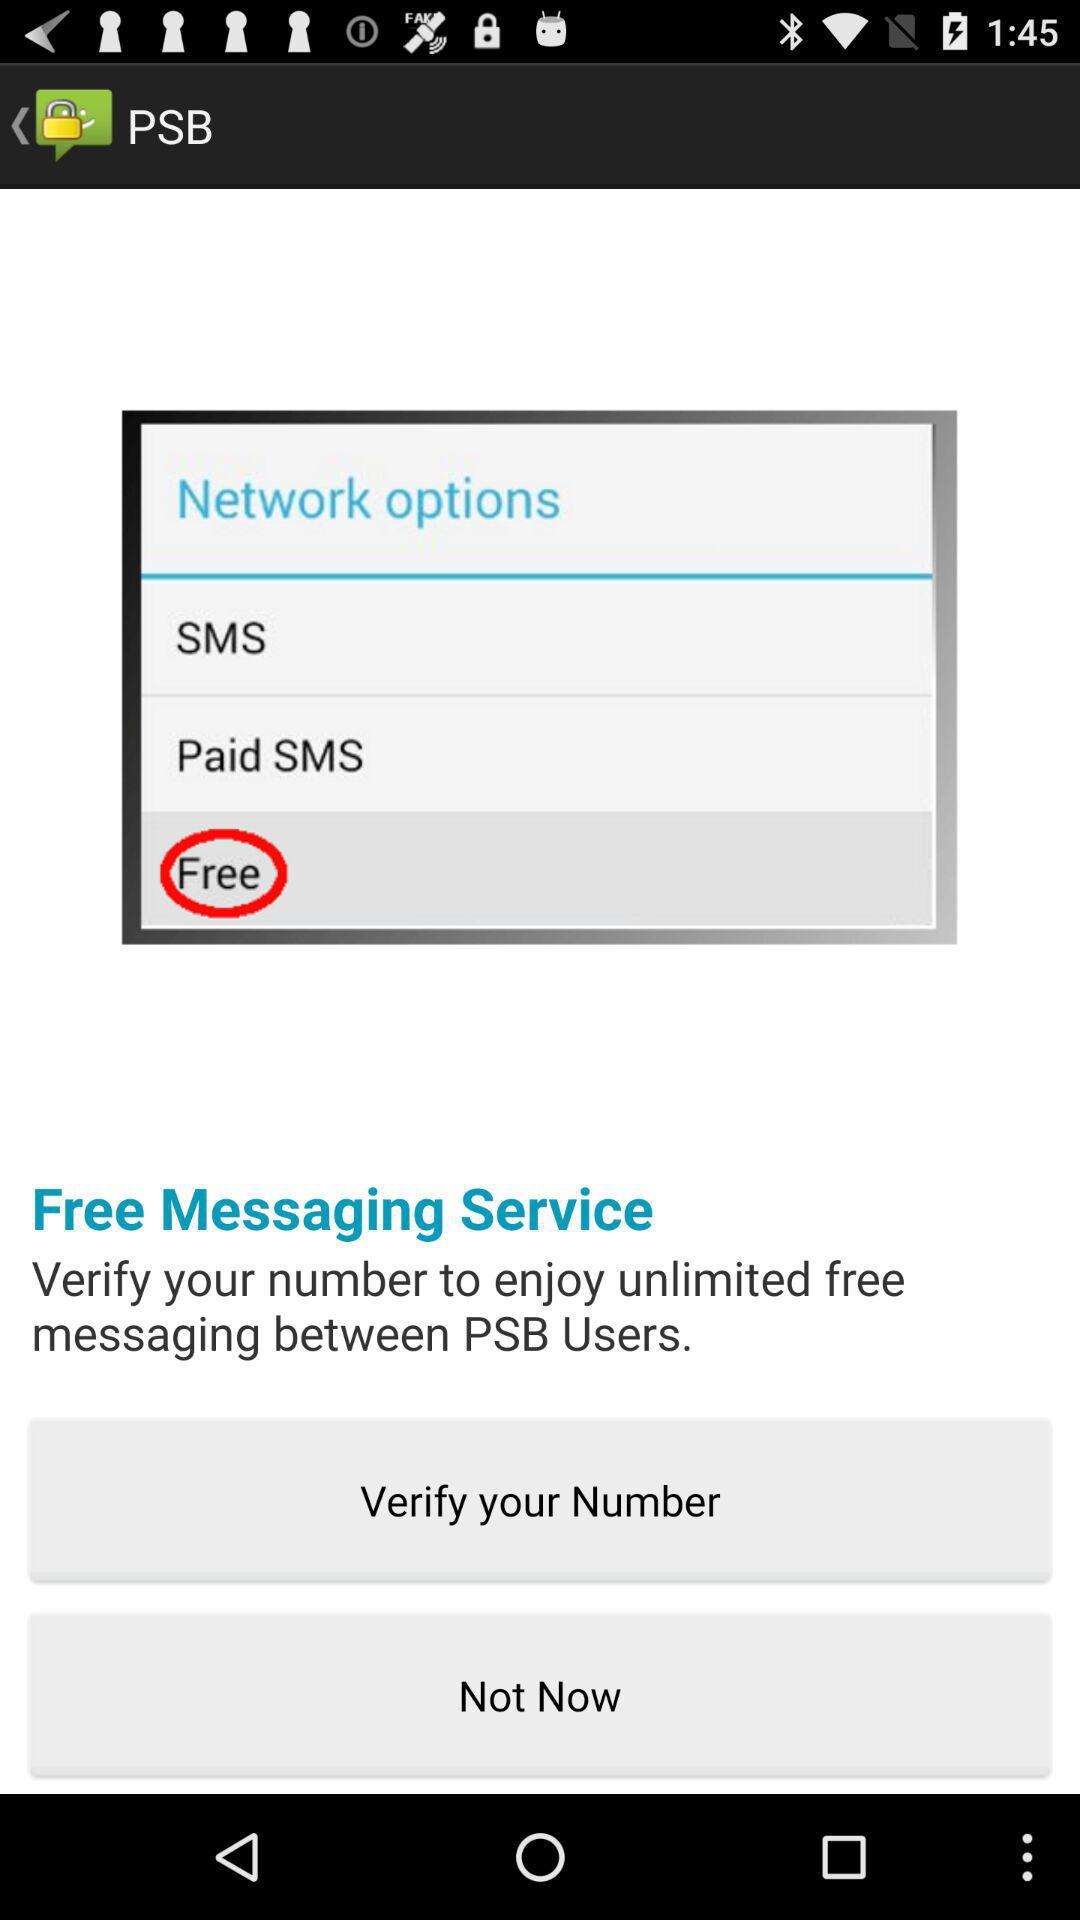Is the messaging service free or paid? The messaging service is free. 